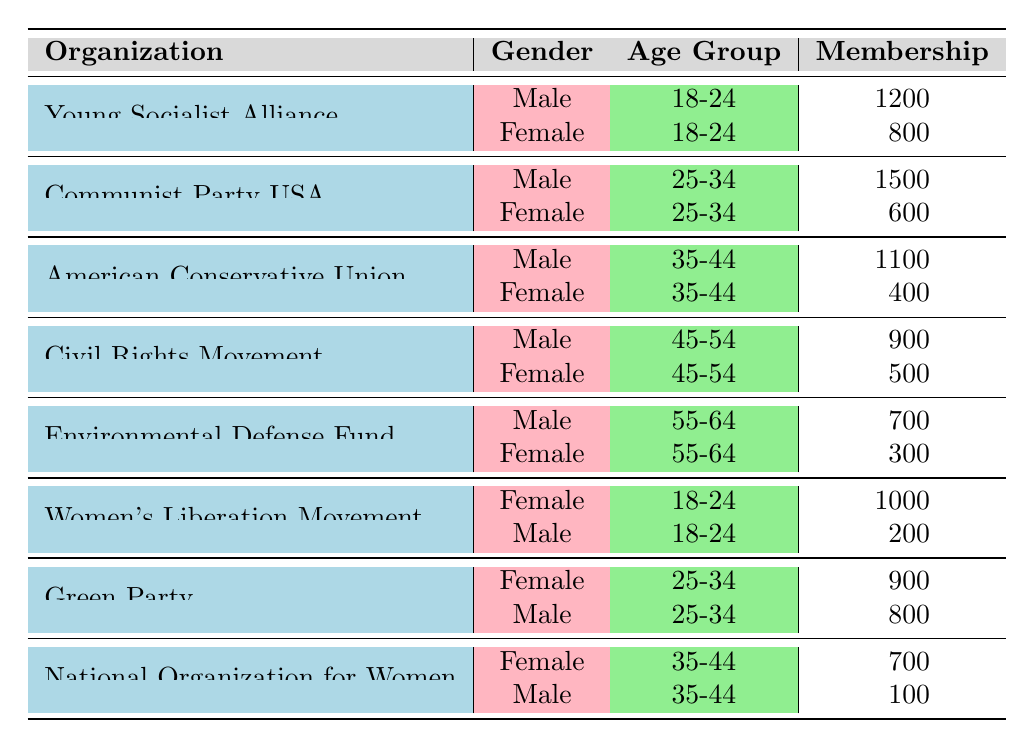What is the total membership of the Young Socialist Alliance? To find the total membership of the Young Socialist Alliance, we look at the rows for this organization. The male membership is 1200 and the female membership is 800. Adding these together, we get 1200 + 800 = 2000.
Answer: 2000 Which gender had more members in the Communist Party USA for the age group 25-34? Looking at the rows for the Communist Party USA in the age group 25-34, the male membership is 1500 and the female membership is 600. Since 1500 is greater than 600, males had more members.
Answer: Male What is the difference in membership between the American Conservative Union and the National Organization for Women for females in the age group 35-44? For females in the age group 35-44, the American Conservative Union has 400 members, while the National Organization for Women has 700 members. The difference is calculated as 700 - 400 = 300.
Answer: 300 Did more females belong to the Women’s Liberation Movement than males in the age group 18-24? In the age group 18-24, females in the Women’s Liberation Movement have 1000 members, while males have 200 members. Since 1000 is greater than 200, the statement is true.
Answer: Yes What is the average membership for males in the 25-34 age group across multiple organizations? The organizations included are the Communist Party USA with 1500 members and the Green Party with 800 members. To find the average, we sum the memberships: 1500 + 800 = 2300 and divide by the number of organizations, which is 2. Thus, the average is 2300 / 2 = 1150.
Answer: 1150 What is the total membership of females in the Environmental Defense Fund and the Civil Rights Movement in the age group 55-64? In the Environmental Defense Fund, females have 300 members, and in the Civil Rights Movement, females have 500 members. We add these numbers together: 300 + 500 = 800.
Answer: 800 For the age group 45-54, which organization had the highest membership for females? Looking through the table, the Civil Rights Movement has a female membership of 500, while the other organizations do not have females in this age group. Therefore, the Civil Rights Movement has the highest female membership in the age group 45-54.
Answer: Civil Rights Movement What is the total membership count for the Green Party across both genders in the 25-34 age group? For the Green Party, males have 800 members and females have 900 members. We add these two figures together: 800 + 900 = 1700, which gives the total membership for the Green Party in that age group.
Answer: 1700 